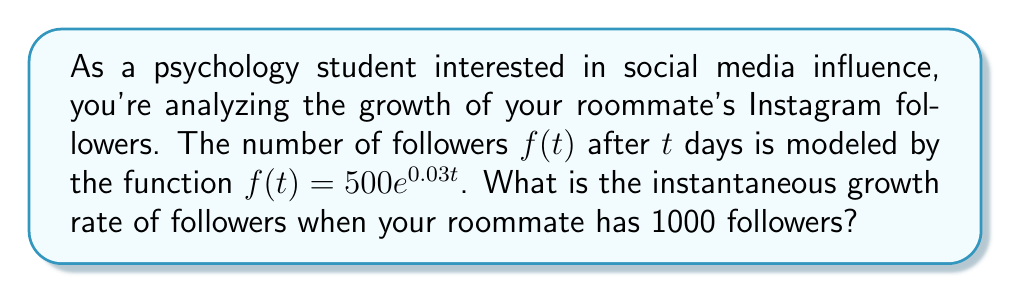What is the answer to this math problem? To find the instantaneous growth rate, we need to calculate the derivative of the function at the point where $f(t) = 1000$.

Step 1: Find the derivative of $f(t)$.
$$f'(t) = 500 \cdot 0.03e^{0.03t} = 15e^{0.03t}$$

Step 2: Determine the time $t$ when $f(t) = 1000$.
$$1000 = 500e^{0.03t}$$
$$2 = e^{0.03t}$$
$$\ln(2) = 0.03t$$
$$t = \frac{\ln(2)}{0.03} \approx 23.1049$$

Step 3: Calculate the instantaneous growth rate by evaluating $f'(t)$ at $t \approx 23.1049$.
$$f'(23.1049) = 15e^{0.03 \cdot 23.1049} = 15 \cdot 2 = 30$$

Therefore, when your roommate has 1000 followers, the instantaneous growth rate is 30 followers per day.
Answer: 30 followers/day 